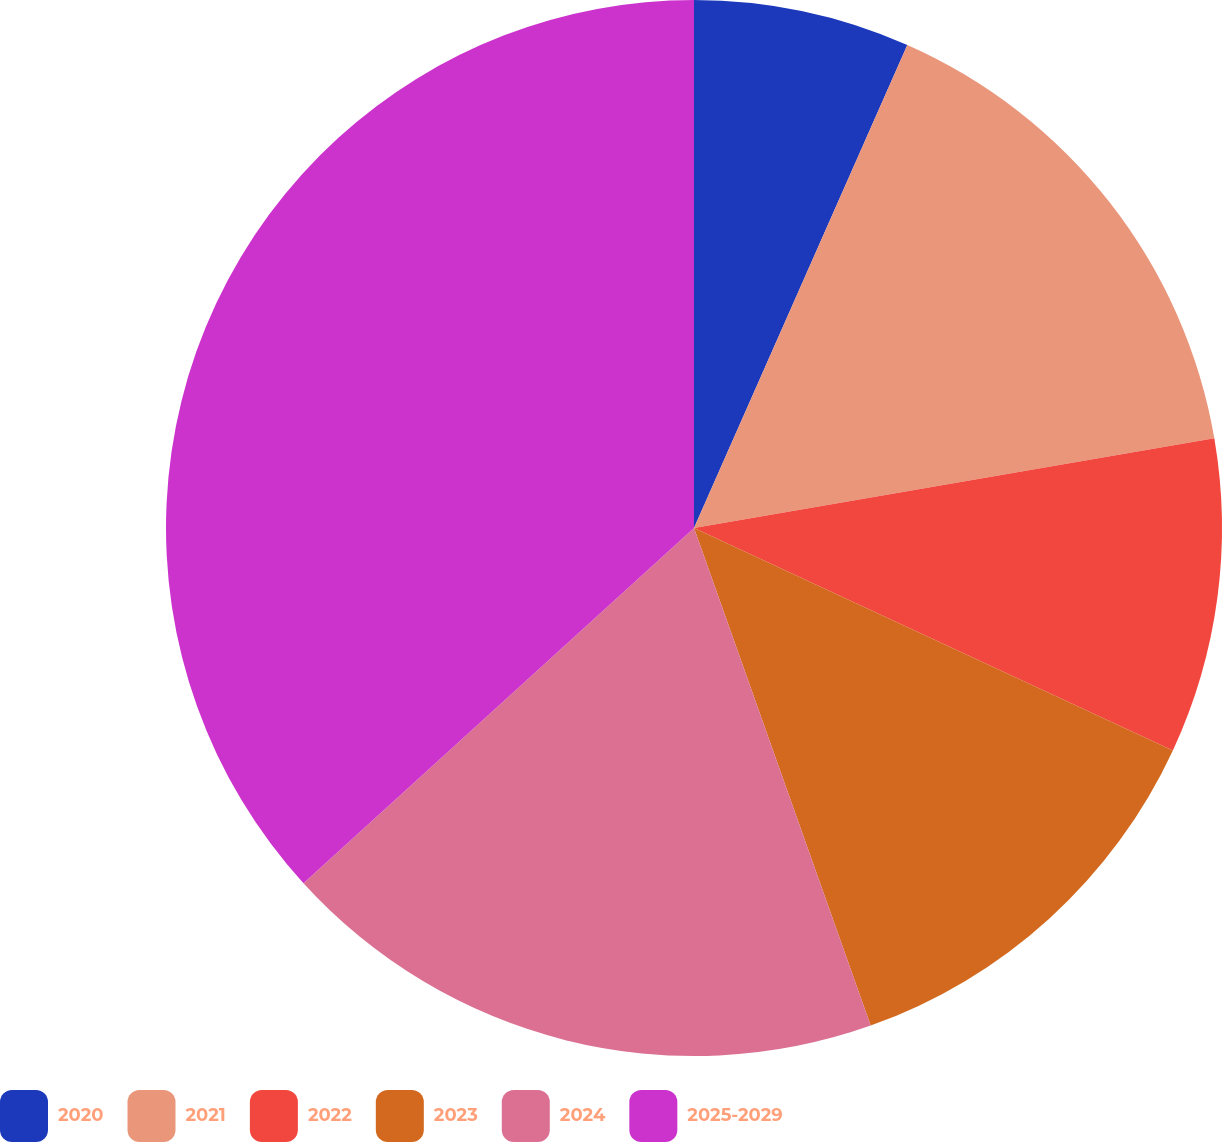<chart> <loc_0><loc_0><loc_500><loc_500><pie_chart><fcel>2020<fcel>2021<fcel>2022<fcel>2023<fcel>2024<fcel>2025-2029<nl><fcel>6.62%<fcel>15.66%<fcel>9.64%<fcel>12.65%<fcel>18.68%<fcel>36.75%<nl></chart> 